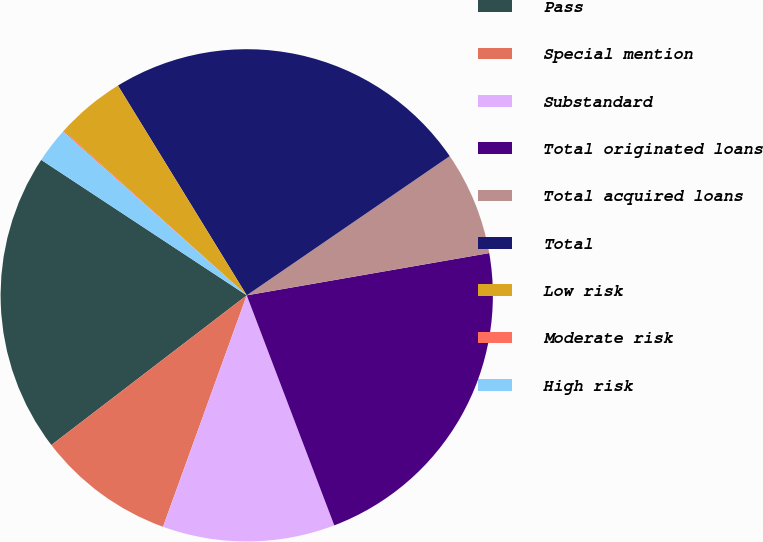Convert chart to OTSL. <chart><loc_0><loc_0><loc_500><loc_500><pie_chart><fcel>Pass<fcel>Special mention<fcel>Substandard<fcel>Total originated loans<fcel>Total acquired loans<fcel>Total<fcel>Low risk<fcel>Moderate risk<fcel>High risk<nl><fcel>19.68%<fcel>9.07%<fcel>11.31%<fcel>21.96%<fcel>6.82%<fcel>24.2%<fcel>4.57%<fcel>0.07%<fcel>2.32%<nl></chart> 